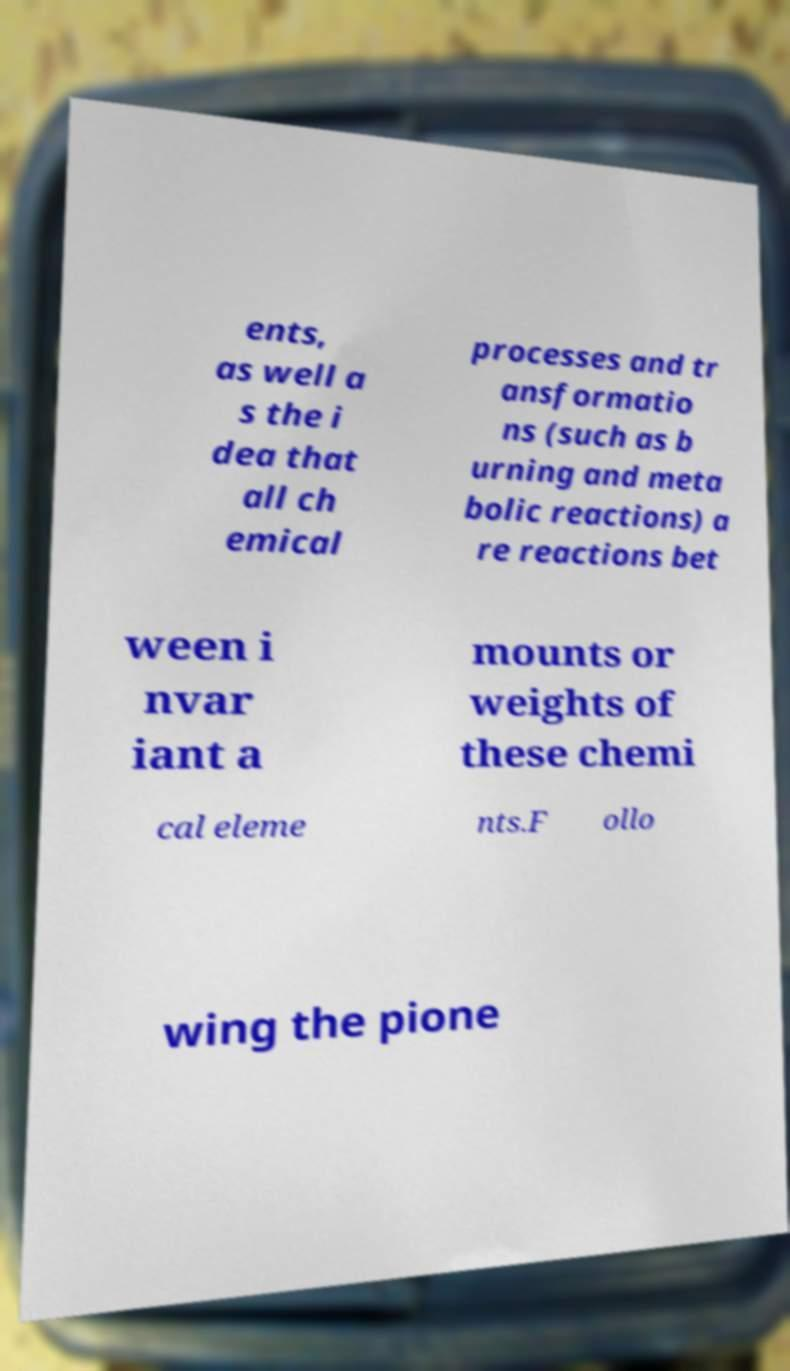Could you assist in decoding the text presented in this image and type it out clearly? ents, as well a s the i dea that all ch emical processes and tr ansformatio ns (such as b urning and meta bolic reactions) a re reactions bet ween i nvar iant a mounts or weights of these chemi cal eleme nts.F ollo wing the pione 